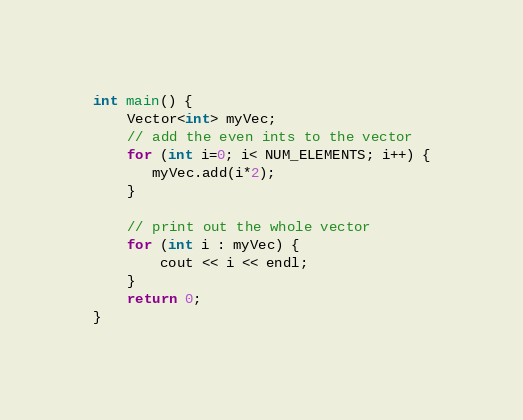<code> <loc_0><loc_0><loc_500><loc_500><_C++_>
int main() {
    Vector<int> myVec;
    // add the even ints to the vector
    for (int i=0; i< NUM_ELEMENTS; i++) {
       myVec.add(i*2);
    }

    // print out the whole vector
    for (int i : myVec) {
        cout << i << endl;
    }
    return 0;
}

</code> 